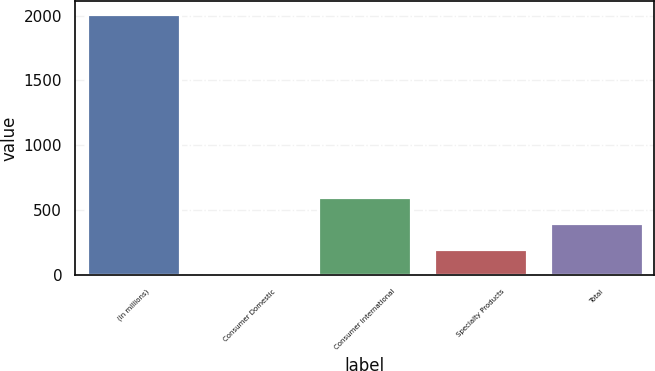Convert chart to OTSL. <chart><loc_0><loc_0><loc_500><loc_500><bar_chart><fcel>(In millions)<fcel>Consumer Domestic<fcel>Consumer International<fcel>Specialty Products<fcel>Total<nl><fcel>2010<fcel>0.6<fcel>603.42<fcel>201.54<fcel>402.48<nl></chart> 